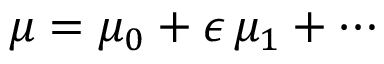<formula> <loc_0><loc_0><loc_500><loc_500>\mu = \mu _ { 0 } + \epsilon \, \mu _ { 1 } + \cdots</formula> 